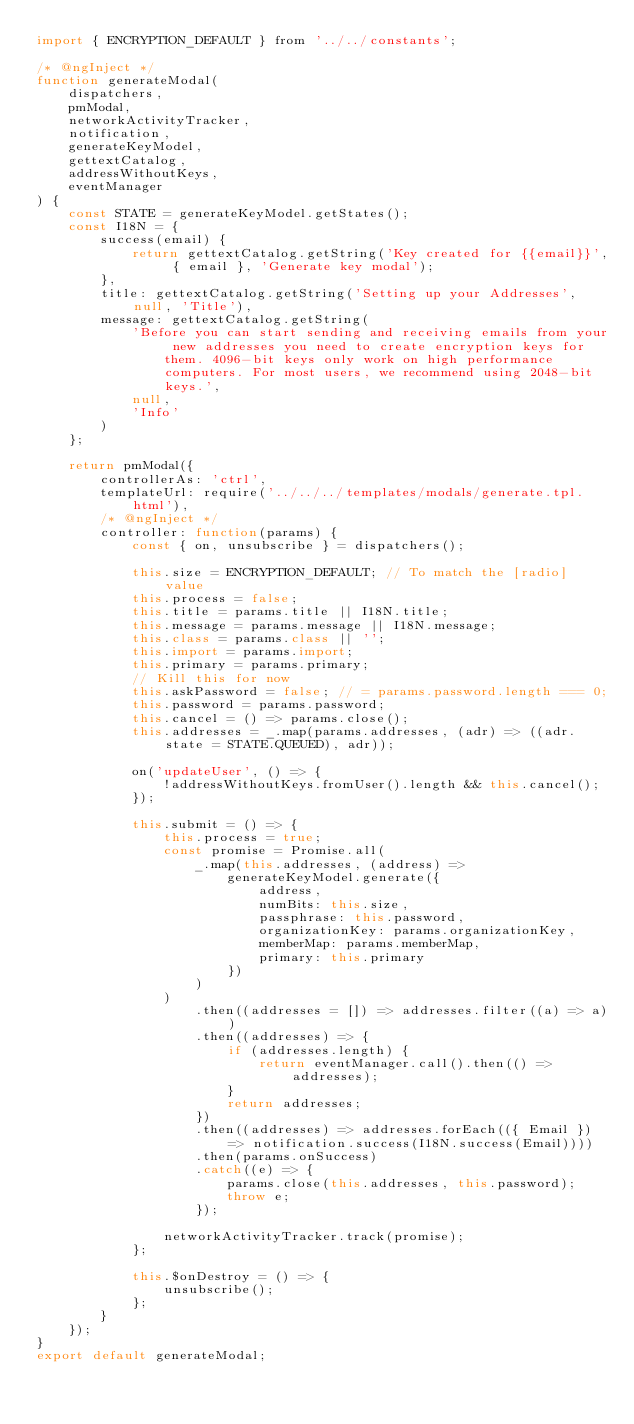<code> <loc_0><loc_0><loc_500><loc_500><_JavaScript_>import { ENCRYPTION_DEFAULT } from '../../constants';

/* @ngInject */
function generateModal(
    dispatchers,
    pmModal,
    networkActivityTracker,
    notification,
    generateKeyModel,
    gettextCatalog,
    addressWithoutKeys,
    eventManager
) {
    const STATE = generateKeyModel.getStates();
    const I18N = {
        success(email) {
            return gettextCatalog.getString('Key created for {{email}}', { email }, 'Generate key modal');
        },
        title: gettextCatalog.getString('Setting up your Addresses', null, 'Title'),
        message: gettextCatalog.getString(
            'Before you can start sending and receiving emails from your new addresses you need to create encryption keys for them. 4096-bit keys only work on high performance computers. For most users, we recommend using 2048-bit keys.',
            null,
            'Info'
        )
    };

    return pmModal({
        controllerAs: 'ctrl',
        templateUrl: require('../../../templates/modals/generate.tpl.html'),
        /* @ngInject */
        controller: function(params) {
            const { on, unsubscribe } = dispatchers();

            this.size = ENCRYPTION_DEFAULT; // To match the [radio] value
            this.process = false;
            this.title = params.title || I18N.title;
            this.message = params.message || I18N.message;
            this.class = params.class || '';
            this.import = params.import;
            this.primary = params.primary;
            // Kill this for now
            this.askPassword = false; // = params.password.length === 0;
            this.password = params.password;
            this.cancel = () => params.close();
            this.addresses = _.map(params.addresses, (adr) => ((adr.state = STATE.QUEUED), adr));

            on('updateUser', () => {
                !addressWithoutKeys.fromUser().length && this.cancel();
            });

            this.submit = () => {
                this.process = true;
                const promise = Promise.all(
                    _.map(this.addresses, (address) =>
                        generateKeyModel.generate({
                            address,
                            numBits: this.size,
                            passphrase: this.password,
                            organizationKey: params.organizationKey,
                            memberMap: params.memberMap,
                            primary: this.primary
                        })
                    )
                )
                    .then((addresses = []) => addresses.filter((a) => a))
                    .then((addresses) => {
                        if (addresses.length) {
                            return eventManager.call().then(() => addresses);
                        }
                        return addresses;
                    })
                    .then((addresses) => addresses.forEach(({ Email }) => notification.success(I18N.success(Email))))
                    .then(params.onSuccess)
                    .catch((e) => {
                        params.close(this.addresses, this.password);
                        throw e;
                    });

                networkActivityTracker.track(promise);
            };

            this.$onDestroy = () => {
                unsubscribe();
            };
        }
    });
}
export default generateModal;
</code> 